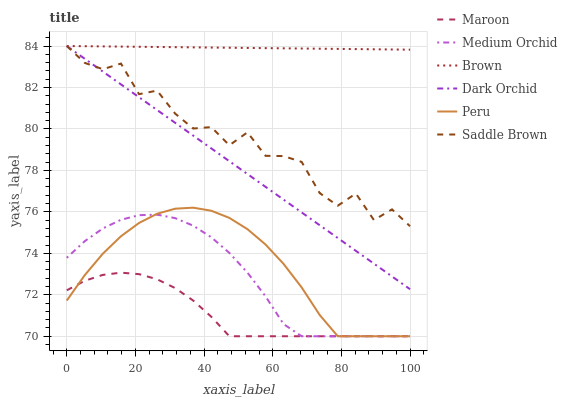Does Maroon have the minimum area under the curve?
Answer yes or no. Yes. Does Brown have the maximum area under the curve?
Answer yes or no. Yes. Does Medium Orchid have the minimum area under the curve?
Answer yes or no. No. Does Medium Orchid have the maximum area under the curve?
Answer yes or no. No. Is Dark Orchid the smoothest?
Answer yes or no. Yes. Is Saddle Brown the roughest?
Answer yes or no. Yes. Is Medium Orchid the smoothest?
Answer yes or no. No. Is Medium Orchid the roughest?
Answer yes or no. No. Does Medium Orchid have the lowest value?
Answer yes or no. Yes. Does Dark Orchid have the lowest value?
Answer yes or no. No. Does Saddle Brown have the highest value?
Answer yes or no. Yes. Does Medium Orchid have the highest value?
Answer yes or no. No. Is Medium Orchid less than Dark Orchid?
Answer yes or no. Yes. Is Dark Orchid greater than Peru?
Answer yes or no. Yes. Does Medium Orchid intersect Peru?
Answer yes or no. Yes. Is Medium Orchid less than Peru?
Answer yes or no. No. Is Medium Orchid greater than Peru?
Answer yes or no. No. Does Medium Orchid intersect Dark Orchid?
Answer yes or no. No. 